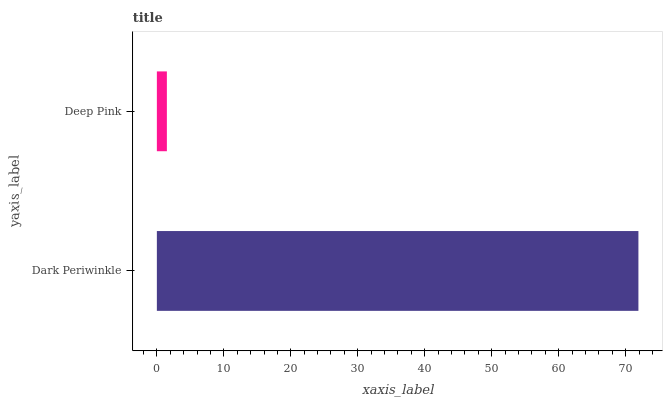Is Deep Pink the minimum?
Answer yes or no. Yes. Is Dark Periwinkle the maximum?
Answer yes or no. Yes. Is Deep Pink the maximum?
Answer yes or no. No. Is Dark Periwinkle greater than Deep Pink?
Answer yes or no. Yes. Is Deep Pink less than Dark Periwinkle?
Answer yes or no. Yes. Is Deep Pink greater than Dark Periwinkle?
Answer yes or no. No. Is Dark Periwinkle less than Deep Pink?
Answer yes or no. No. Is Dark Periwinkle the high median?
Answer yes or no. Yes. Is Deep Pink the low median?
Answer yes or no. Yes. Is Deep Pink the high median?
Answer yes or no. No. Is Dark Periwinkle the low median?
Answer yes or no. No. 